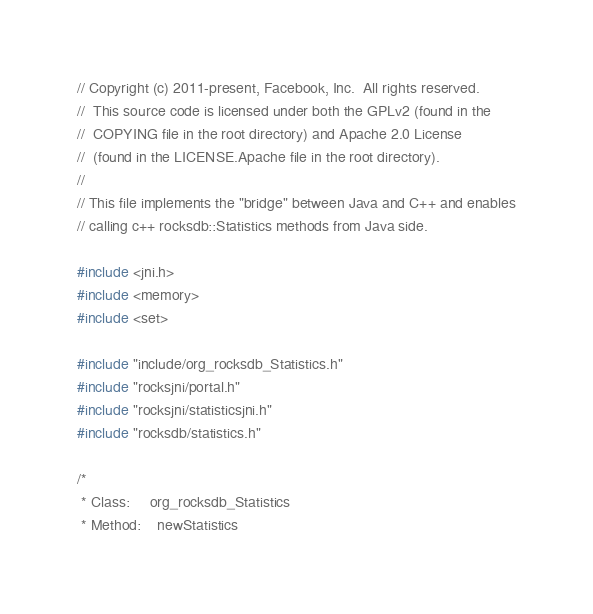<code> <loc_0><loc_0><loc_500><loc_500><_C++_>// Copyright (c) 2011-present, Facebook, Inc.  All rights reserved.
//  This source code is licensed under both the GPLv2 (found in the
//  COPYING file in the root directory) and Apache 2.0 License
//  (found in the LICENSE.Apache file in the root directory).
//
// This file implements the "bridge" between Java and C++ and enables
// calling c++ rocksdb::Statistics methods from Java side.

#include <jni.h>
#include <memory>
#include <set>

#include "include/org_rocksdb_Statistics.h"
#include "rocksjni/portal.h"
#include "rocksjni/statisticsjni.h"
#include "rocksdb/statistics.h"

/*
 * Class:     org_rocksdb_Statistics
 * Method:    newStatistics</code> 